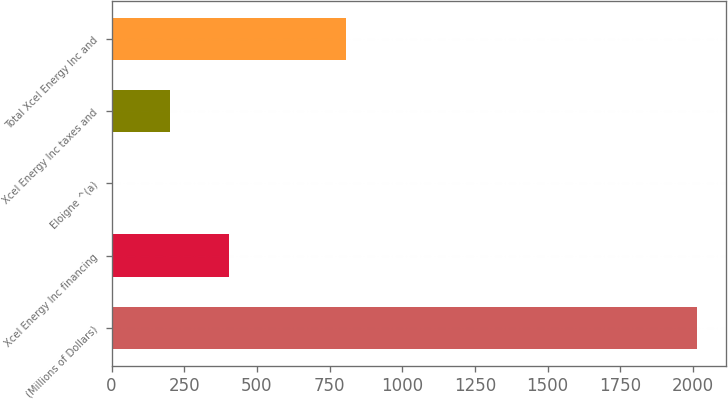Convert chart to OTSL. <chart><loc_0><loc_0><loc_500><loc_500><bar_chart><fcel>(Millions of Dollars)<fcel>Xcel Energy Inc financing<fcel>Eloigne ^(a)<fcel>Xcel Energy Inc taxes and<fcel>Total Xcel Energy Inc and<nl><fcel>2013<fcel>403.24<fcel>0.8<fcel>202.02<fcel>805.68<nl></chart> 